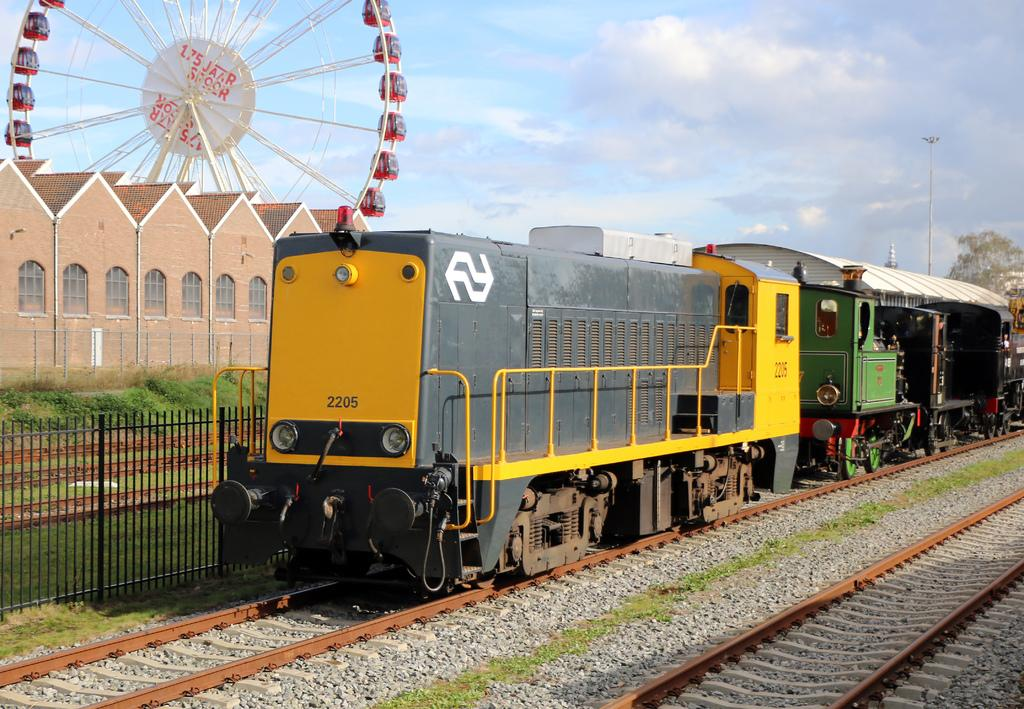What is the main subject of the image? The main subject of the image is a train on the track. What can be seen in the foreground of the image? There are railway tracks and a fence in the foreground of the image. What is visible in the background of the image? There is a building, a tree, a giant wheel, poles, and the sky visible in the background of the image. How many chairs are present in the image? There are no chairs visible in the image. Does the existence of the train in the image prove the existence of magic? The presence of a train in the image does not prove the existence of magic, as trains are a real-world object and not related to magic. 